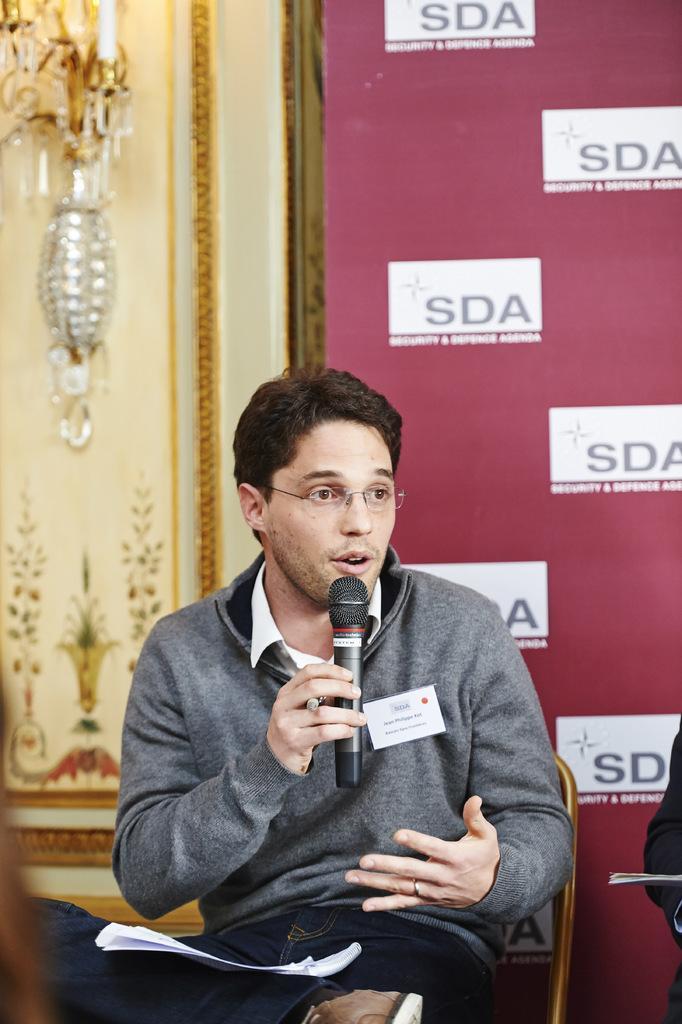Can you describe this image briefly? In this picture we can see a man who is sitting on the chair. He is holding a mike with his hand and he has spectacles. On the background we can see a banner. 